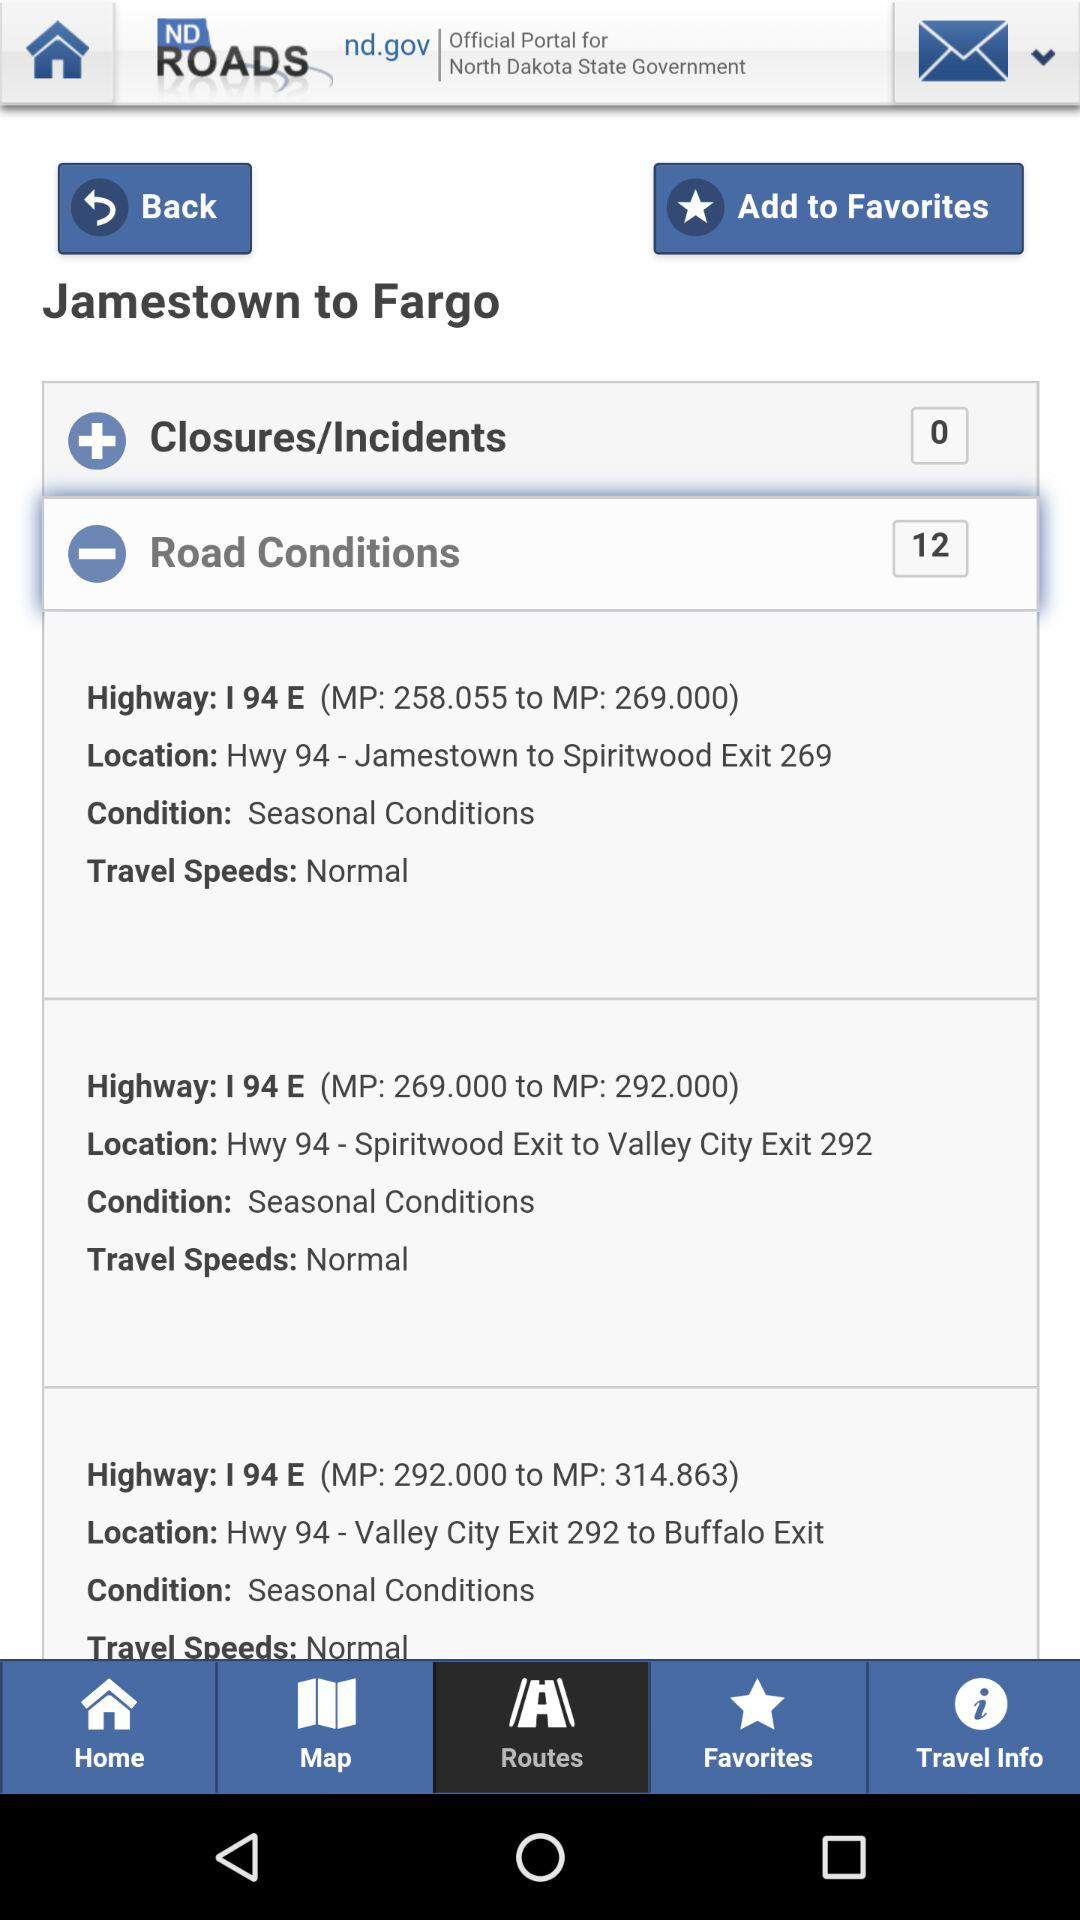How many "Road Conditions" in total are there? There are 12 "Road Conditions". 